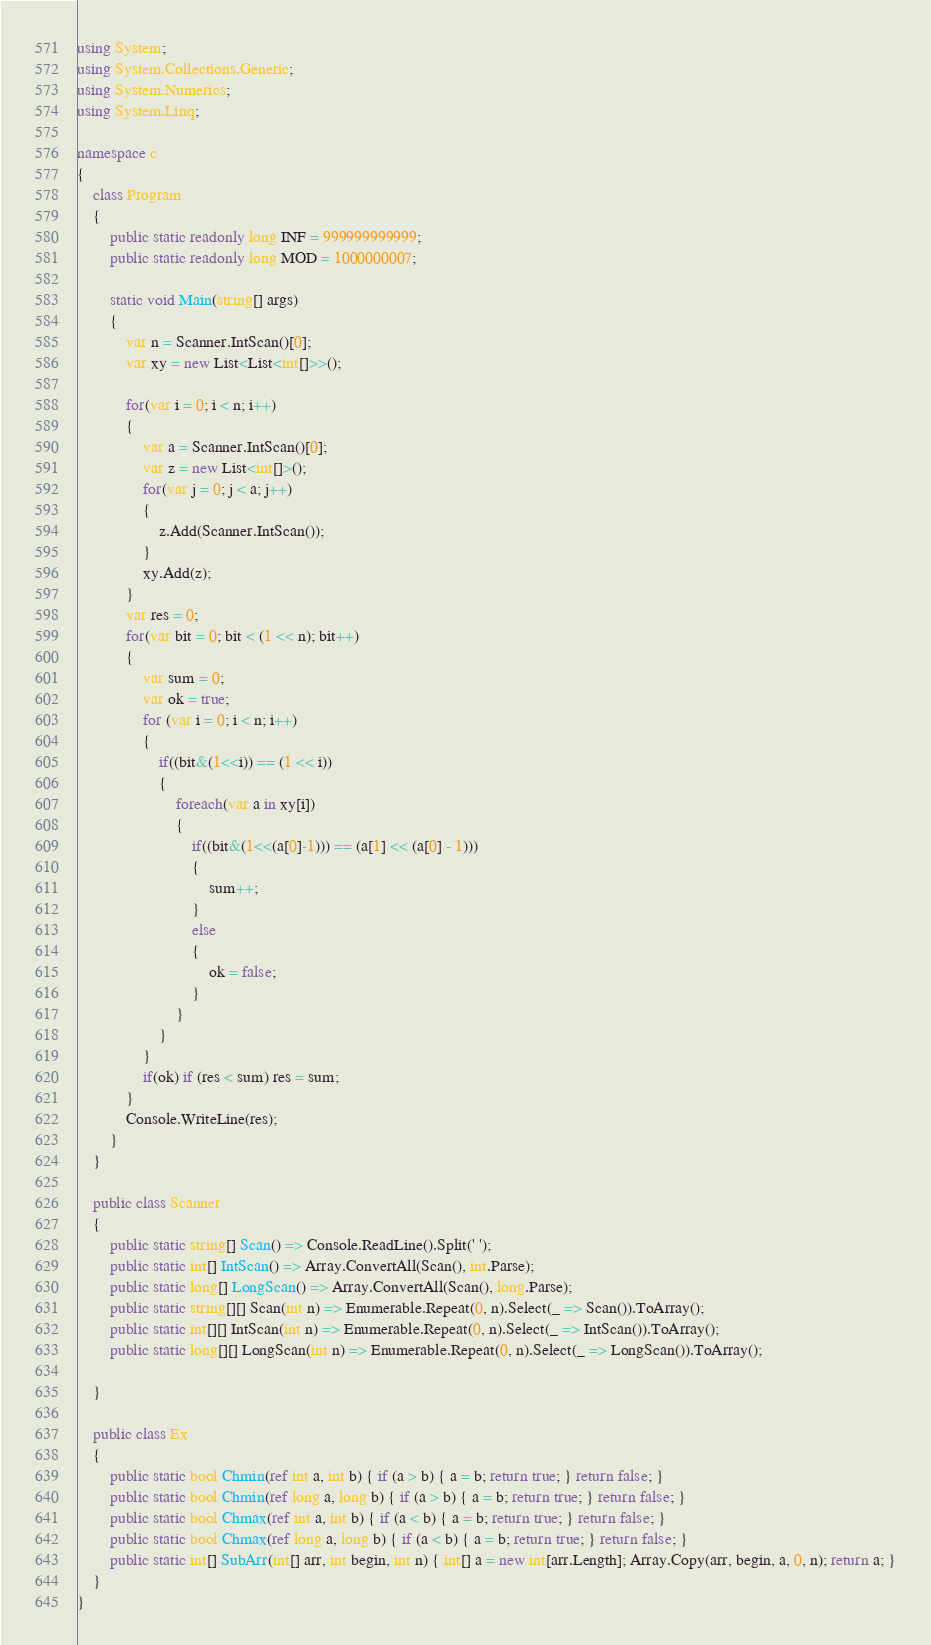Convert code to text. <code><loc_0><loc_0><loc_500><loc_500><_C#_>using System;
using System.Collections.Generic;
using System.Numerics;
using System.Linq;

namespace c
{
    class Program
    {
        public static readonly long INF = 999999999999;
        public static readonly long MOD = 1000000007;

        static void Main(string[] args)
        {
            var n = Scanner.IntScan()[0];
            var xy = new List<List<int[]>>();

            for(var i = 0; i < n; i++)
            {
                var a = Scanner.IntScan()[0];
                var z = new List<int[]>();
                for(var j = 0; j < a; j++)
                {
                    z.Add(Scanner.IntScan());
                }
                xy.Add(z);
            }
            var res = 0;
            for(var bit = 0; bit < (1 << n); bit++)
            {
                var sum = 0;
                var ok = true;
                for (var i = 0; i < n; i++)
                {
                    if((bit&(1<<i)) == (1 << i))
                    {
                        foreach(var a in xy[i])
                        {
                            if((bit&(1<<(a[0]-1))) == (a[1] << (a[0] - 1)))
                            {
                                sum++;
                            }
                            else
                            {
                                ok = false;
                            }
                        }
                    }
                }
                if(ok) if (res < sum) res = sum;
            }
            Console.WriteLine(res);
        }
    }

    public class Scanner
    {
        public static string[] Scan() => Console.ReadLine().Split(' ');
        public static int[] IntScan() => Array.ConvertAll(Scan(), int.Parse);
        public static long[] LongScan() => Array.ConvertAll(Scan(), long.Parse);
        public static string[][] Scan(int n) => Enumerable.Repeat(0, n).Select(_ => Scan()).ToArray();
        public static int[][] IntScan(int n) => Enumerable.Repeat(0, n).Select(_ => IntScan()).ToArray();
        public static long[][] LongScan(int n) => Enumerable.Repeat(0, n).Select(_ => LongScan()).ToArray();

    }

    public class Ex
    {
        public static bool Chmin(ref int a, int b) { if (a > b) { a = b; return true; } return false; }
        public static bool Chmin(ref long a, long b) { if (a > b) { a = b; return true; } return false; }
        public static bool Chmax(ref int a, int b) { if (a < b) { a = b; return true; } return false; }
        public static bool Chmax(ref long a, long b) { if (a < b) { a = b; return true; } return false; }
        public static int[] SubArr(int[] arr, int begin, int n) { int[] a = new int[arr.Length]; Array.Copy(arr, begin, a, 0, n); return a; }
    }
}
</code> 